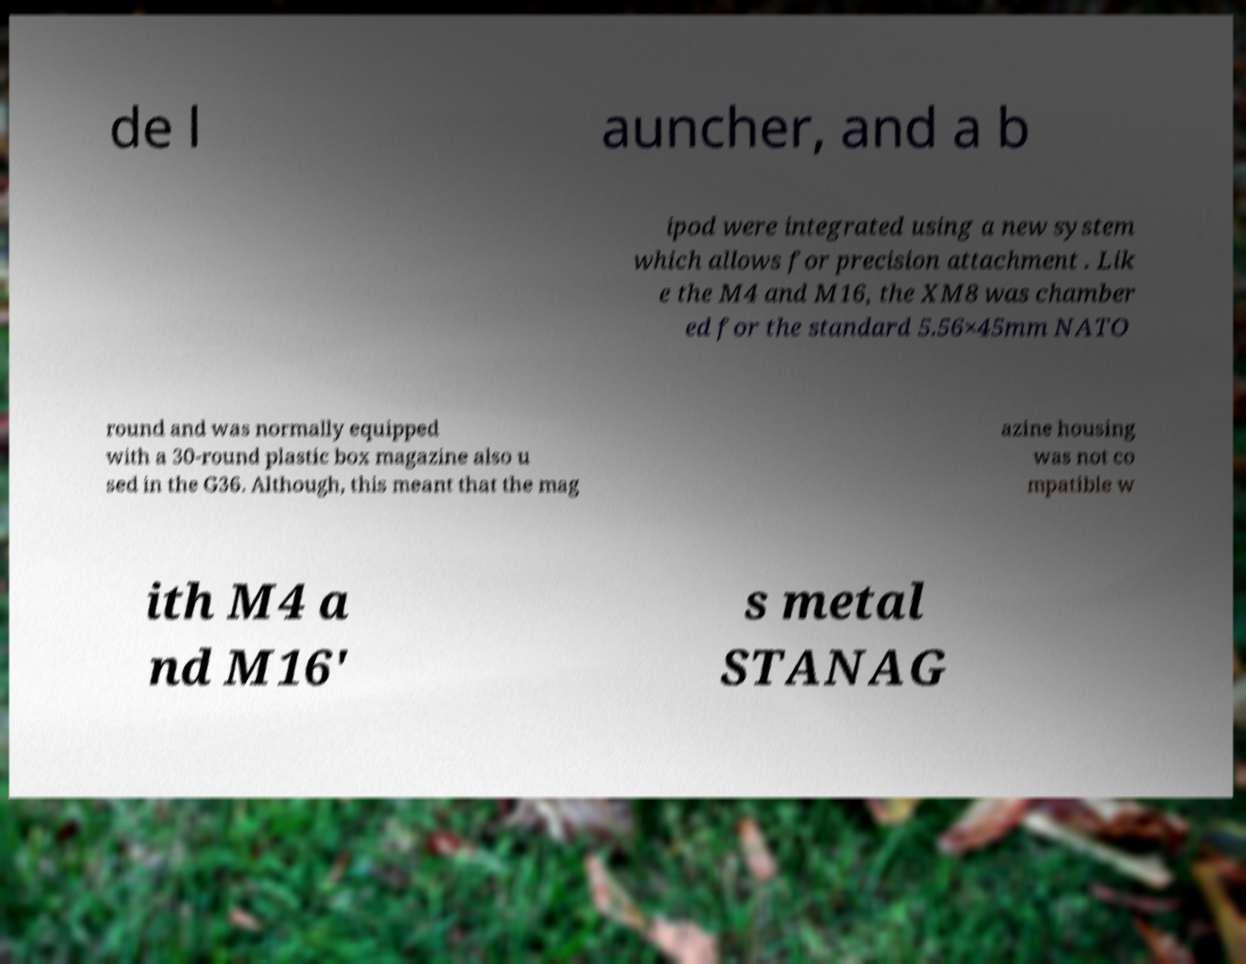Could you extract and type out the text from this image? de l auncher, and a b ipod were integrated using a new system which allows for precision attachment . Lik e the M4 and M16, the XM8 was chamber ed for the standard 5.56×45mm NATO round and was normally equipped with a 30-round plastic box magazine also u sed in the G36. Although, this meant that the mag azine housing was not co mpatible w ith M4 a nd M16' s metal STANAG 